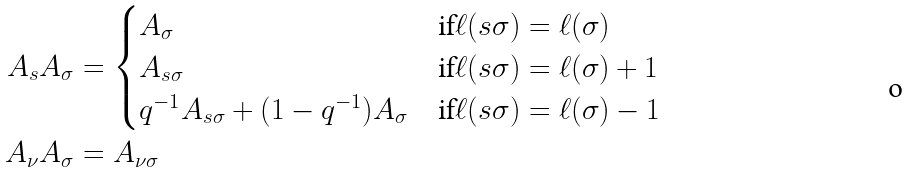Convert formula to latex. <formula><loc_0><loc_0><loc_500><loc_500>A _ { s } A _ { \sigma } & = \begin{cases} A _ { \sigma } & \text {if} \ell ( s \sigma ) = \ell ( \sigma ) \\ A _ { s \sigma } & \text {if} \ell ( s \sigma ) = \ell ( \sigma ) + 1 \\ q ^ { - 1 } A _ { s \sigma } + ( 1 - q ^ { - 1 } ) A _ { \sigma } & \text {if} \ell ( s \sigma ) = \ell ( \sigma ) - 1 \\ \end{cases} \\ A _ { \nu } A _ { \sigma } & = A _ { \nu \sigma }</formula> 